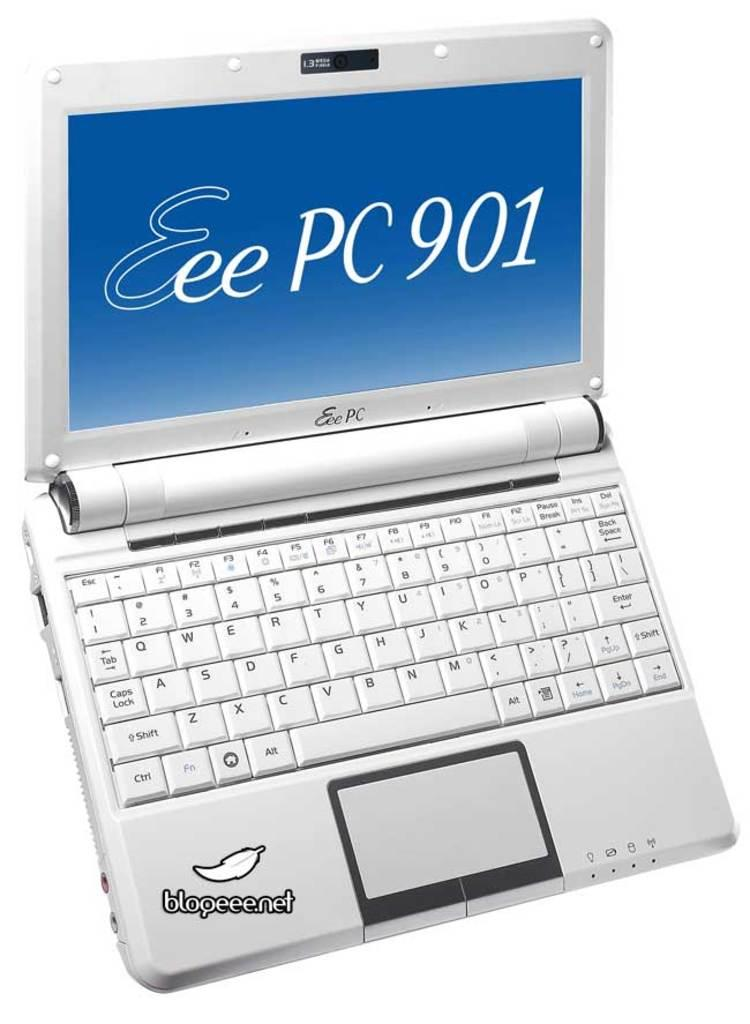Provide a one-sentence caption for the provided image. A laptop is open and shows Eee PC 901 on the screen. 